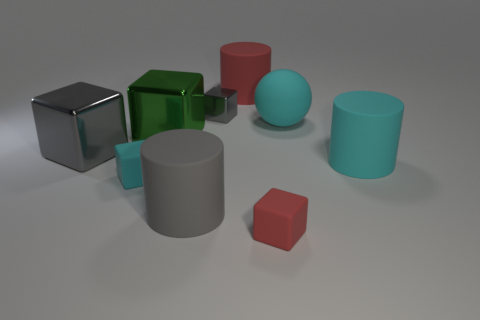Do the red object that is behind the big gray matte cylinder and the big green object that is in front of the rubber sphere have the same material?
Keep it short and to the point. No. How many cubes are both in front of the big gray metal cube and to the left of the gray cylinder?
Make the answer very short. 1. Are there any red things of the same shape as the tiny gray object?
Ensure brevity in your answer.  Yes. There is a gray metal object that is the same size as the cyan rubber cylinder; what is its shape?
Offer a very short reply. Cube. Is the number of large matte balls that are left of the cyan rubber cube the same as the number of large green cubes that are in front of the large gray matte thing?
Your response must be concise. Yes. There is a rubber block that is behind the block that is in front of the gray rubber thing; what is its size?
Provide a succinct answer. Small. Are there any metallic spheres that have the same size as the red matte block?
Keep it short and to the point. No. What color is the other tiny thing that is made of the same material as the tiny cyan thing?
Give a very brief answer. Red. Is the number of metal cubes less than the number of big red rubber cubes?
Give a very brief answer. No. The tiny block that is behind the gray matte cylinder and right of the big gray matte cylinder is made of what material?
Provide a short and direct response. Metal. 